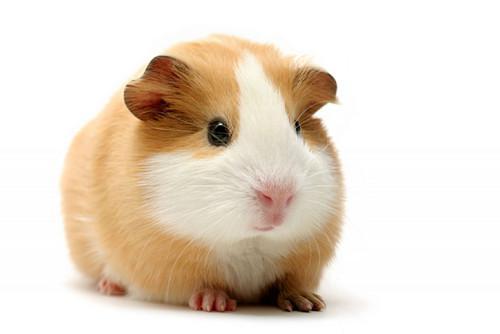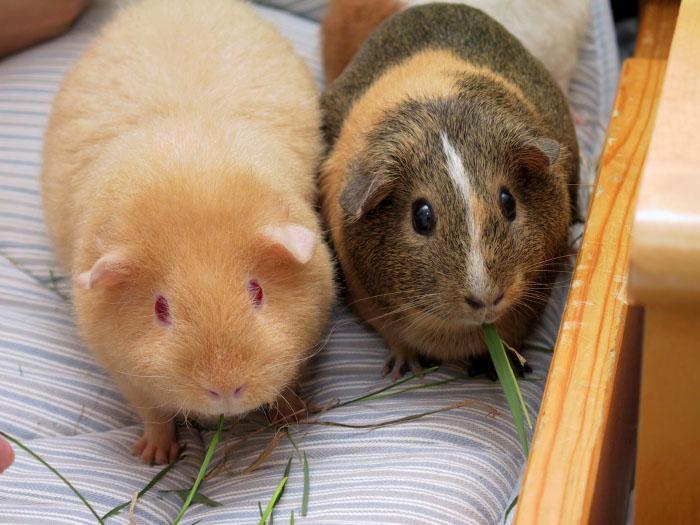The first image is the image on the left, the second image is the image on the right. For the images shown, is this caption "The right image contains at least twice as many guinea pigs as the left image." true? Answer yes or no. Yes. The first image is the image on the left, the second image is the image on the right. Analyze the images presented: Is the assertion "The right image contains at least two guinea pigs." valid? Answer yes or no. Yes. 